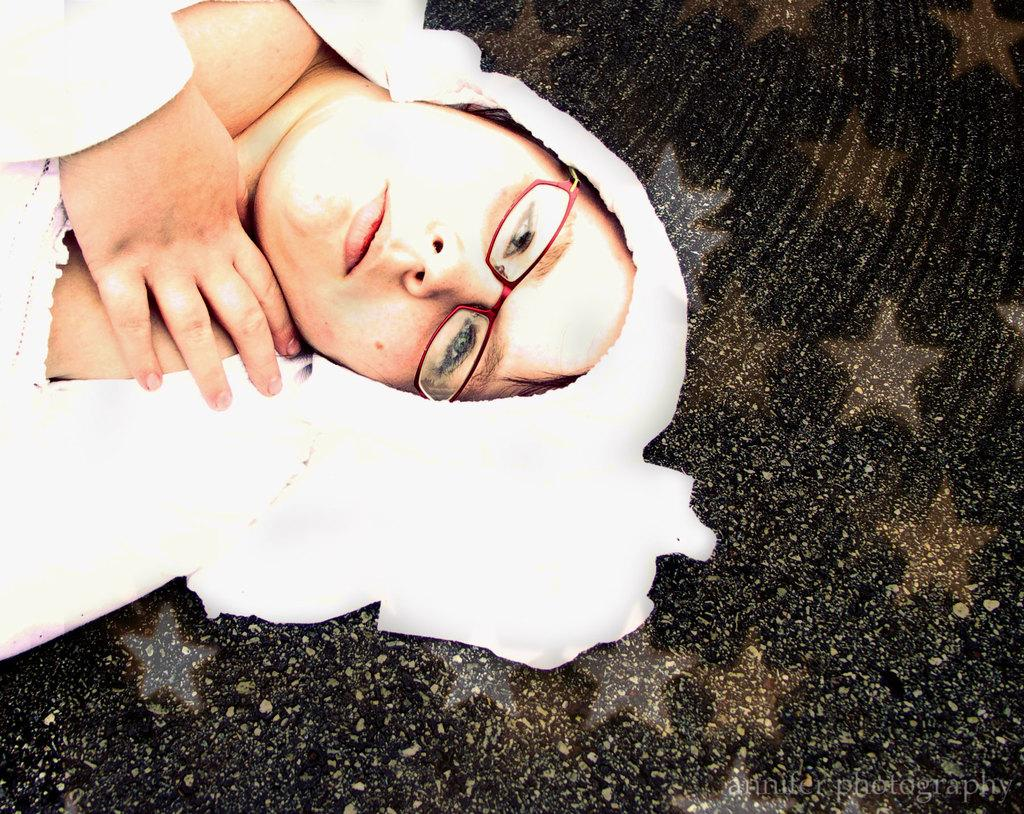Who is the main subject in the image? There is a woman in the image. What is the woman doing in the image? The woman is lying on a surface. What accessory is the woman wearing in the image? The woman is wearing spectacles. What color are the clothes the woman is wearing in the image? The woman is wearing white color clothes. Reasoning: Let' Let's think step by step in order to produce the conversation. We start by identifying the main subject in the image, which is the woman. Then, we describe what the woman is doing in the image, which is lying on a surface. Next, we mention the accessory the woman is wearing, which are spectacles. Finally, we describe the color of the clothes the woman is wearing, which are white. Each question is designed to elicit a specific detail about the image that is known from the provided facts. Absurd Question/Answer: Where is the kitty hiding in the image? There is no kitty present in the image. 